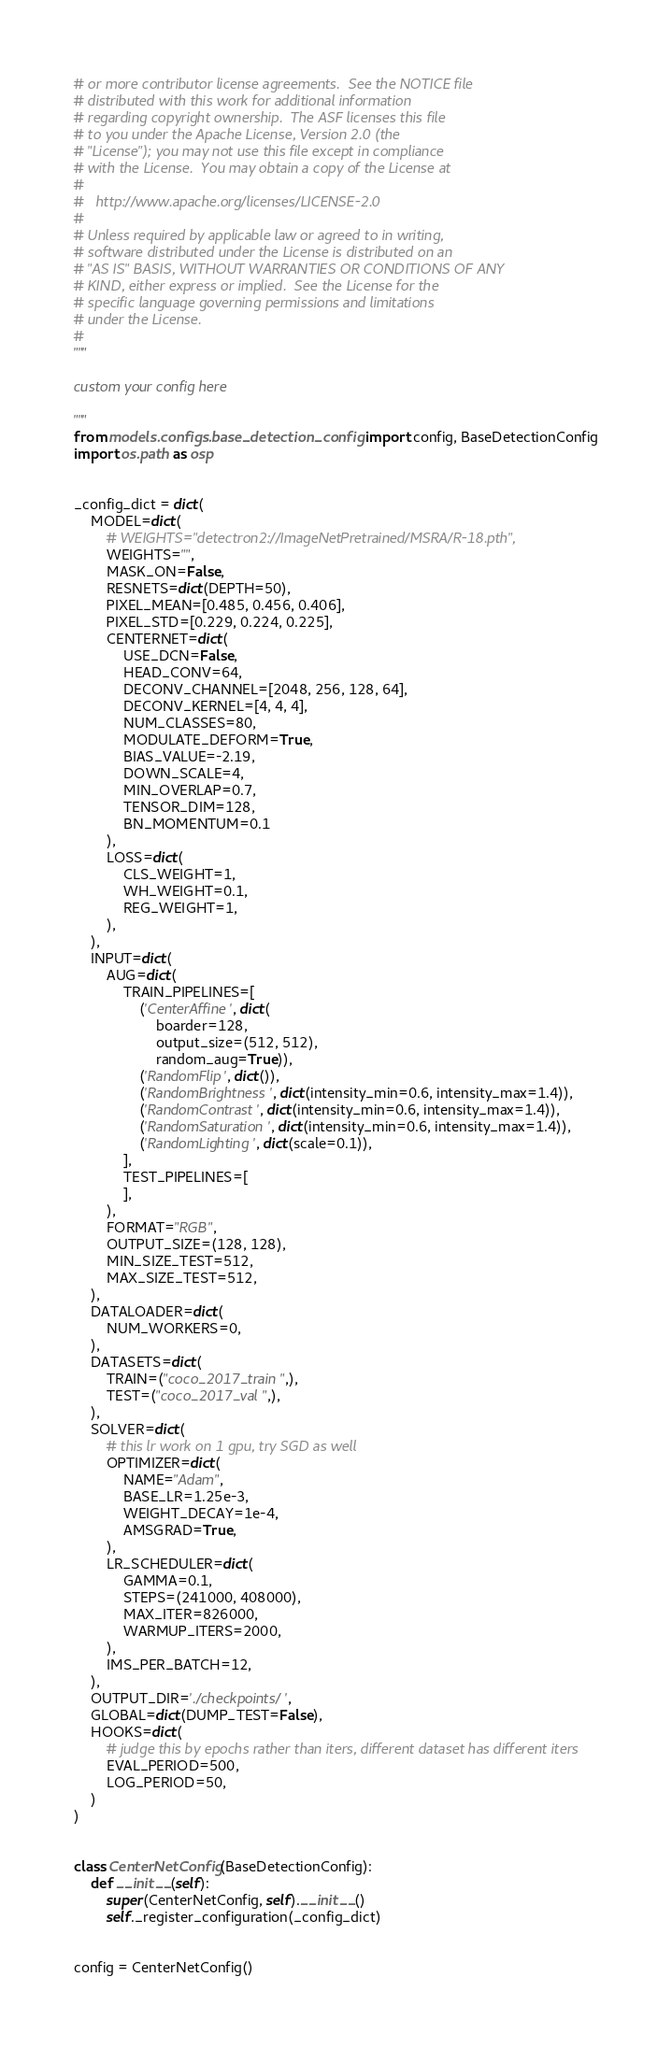Convert code to text. <code><loc_0><loc_0><loc_500><loc_500><_Python_># or more contributor license agreements.  See the NOTICE file
# distributed with this work for additional information
# regarding copyright ownership.  The ASF licenses this file
# to you under the Apache License, Version 2.0 (the
# "License"); you may not use this file except in compliance
# with the License.  You may obtain a copy of the License at
#
#   http://www.apache.org/licenses/LICENSE-2.0
#
# Unless required by applicable law or agreed to in writing,
# software distributed under the License is distributed on an
# "AS IS" BASIS, WITHOUT WARRANTIES OR CONDITIONS OF ANY
# KIND, either express or implied.  See the License for the
# specific language governing permissions and limitations
# under the License.
#
"""

custom your config here

"""
from models.configs.base_detection_config import config, BaseDetectionConfig
import os.path as osp


_config_dict = dict(
    MODEL=dict(
        # WEIGHTS="detectron2://ImageNetPretrained/MSRA/R-18.pth",
        WEIGHTS="",
        MASK_ON=False,
        RESNETS=dict(DEPTH=50),
        PIXEL_MEAN=[0.485, 0.456, 0.406],
        PIXEL_STD=[0.229, 0.224, 0.225],
        CENTERNET=dict(
            USE_DCN=False,
            HEAD_CONV=64,
            DECONV_CHANNEL=[2048, 256, 128, 64],
            DECONV_KERNEL=[4, 4, 4],
            NUM_CLASSES=80,
            MODULATE_DEFORM=True,
            BIAS_VALUE=-2.19,
            DOWN_SCALE=4,
            MIN_OVERLAP=0.7,
            TENSOR_DIM=128,
            BN_MOMENTUM=0.1
        ),
        LOSS=dict(
            CLS_WEIGHT=1,
            WH_WEIGHT=0.1,
            REG_WEIGHT=1,
        ),
    ),
    INPUT=dict(
        AUG=dict(
            TRAIN_PIPELINES=[
                ('CenterAffine', dict(
                    boarder=128,
                    output_size=(512, 512),
                    random_aug=True)),
                ('RandomFlip', dict()),
                ('RandomBrightness', dict(intensity_min=0.6, intensity_max=1.4)),
                ('RandomContrast', dict(intensity_min=0.6, intensity_max=1.4)),
                ('RandomSaturation', dict(intensity_min=0.6, intensity_max=1.4)),
                ('RandomLighting', dict(scale=0.1)),
            ],
            TEST_PIPELINES=[
            ],
        ),
        FORMAT="RGB",
        OUTPUT_SIZE=(128, 128),
        MIN_SIZE_TEST=512,
        MAX_SIZE_TEST=512,
    ),
    DATALOADER=dict(
        NUM_WORKERS=0,
    ),
    DATASETS=dict(
        TRAIN=("coco_2017_train",),
        TEST=("coco_2017_val",),
    ),
    SOLVER=dict(
        # this lr work on 1 gpu, try SGD as well
        OPTIMIZER=dict(
            NAME="Adam",
            BASE_LR=1.25e-3,
            WEIGHT_DECAY=1e-4,
            AMSGRAD=True,
        ),
        LR_SCHEDULER=dict(
            GAMMA=0.1,
            STEPS=(241000, 408000),
            MAX_ITER=826000,
            WARMUP_ITERS=2000,
        ),
        IMS_PER_BATCH=12,
    ),
    OUTPUT_DIR='./checkpoints/',
    GLOBAL=dict(DUMP_TEST=False),
    HOOKS=dict(
        # judge this by epochs rather than iters, different dataset has different iters
        EVAL_PERIOD=500,
        LOG_PERIOD=50,
    )
)


class CenterNetConfig(BaseDetectionConfig):
    def __init__(self):
        super(CenterNetConfig, self).__init__()
        self._register_configuration(_config_dict)


config = CenterNetConfig()</code> 